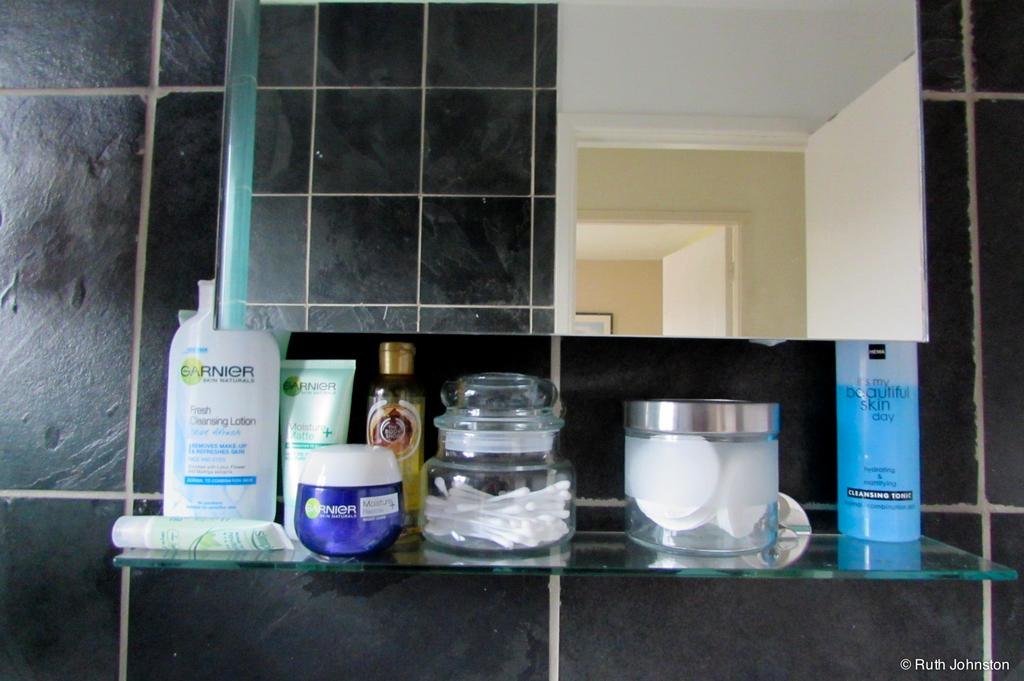Provide a one-sentence caption for the provided image. Personal beauty products line a glass shelf under a mirror, including two Garnier containers. 